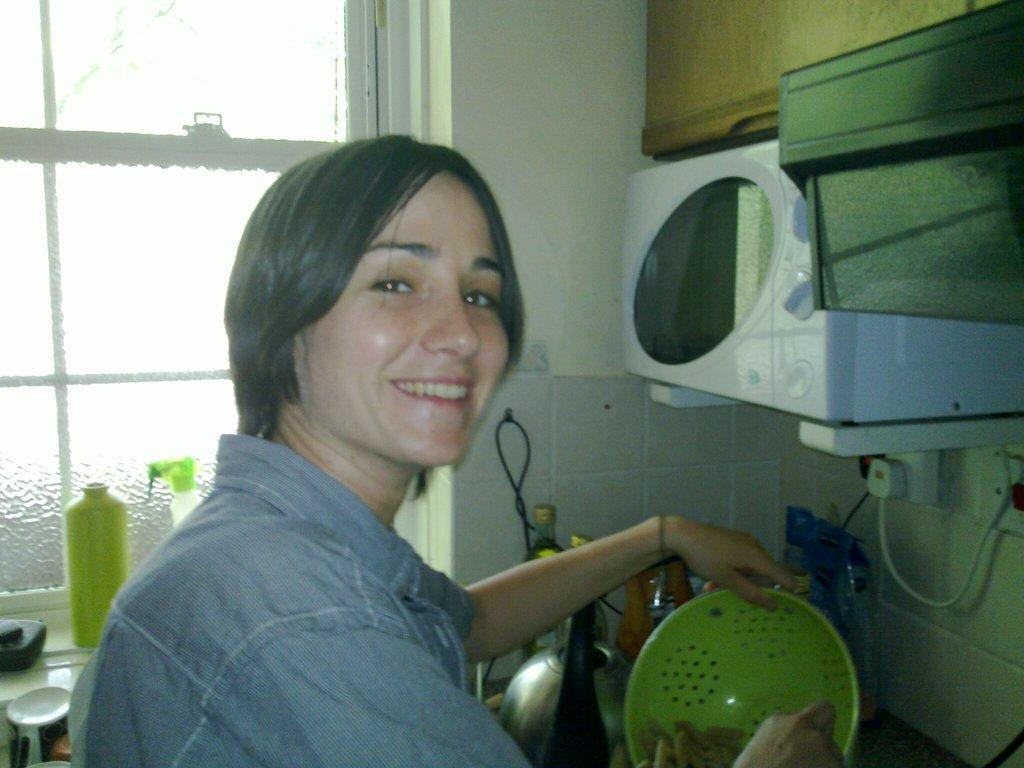Who or what is present in the image? There is a person in the image. What is the person wearing? The person is wearing a shirt. What is the person holding in the image? The person is holding a green-colored bowl. What can be seen in the background of the image? There is a wall and a window in the image. What type of appliance is visible in the image? There is an oven in the image. Are there any wires visible in the image? Yes, there are wires visible in the image. Can you describe any other objects present in the image? There are other objects in the image, but their specific details are not mentioned in the provided facts. What type of statement is written on the paper in the image? There is no paper or statement present in the image. What is the person using the straw for in the image? There is no straw present in the image. 